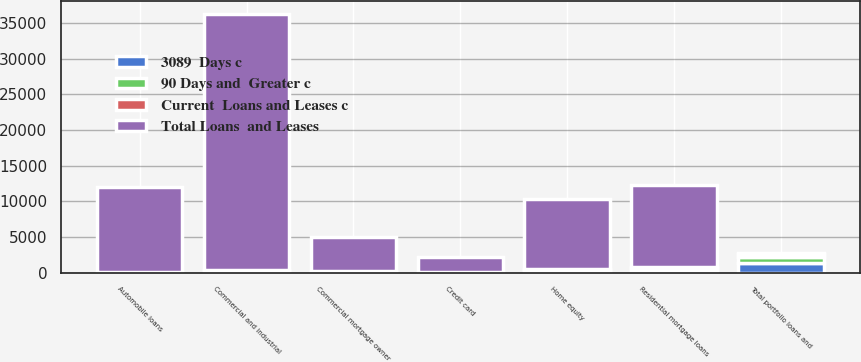<chart> <loc_0><loc_0><loc_500><loc_500><stacked_bar_chart><ecel><fcel>Commercial and industrial<fcel>Commercial mortgage owner<fcel>Residential mortgage loans<fcel>Home equity<fcel>Automobile loans<fcel>Credit card<fcel>Total portfolio loans and<nl><fcel>Total Loans  and Leases<fcel>35826<fcel>4752<fcel>11547<fcel>9782<fcel>11900<fcel>2025<fcel>166<nl><fcel>Current  Loans and Leases c<fcel>46<fcel>29<fcel>87<fcel>126<fcel>62<fcel>38<fcel>413<nl><fcel>90 Days and  Greater c<fcel>166<fcel>95<fcel>307<fcel>110<fcel>10<fcel>34<fcel>912<nl><fcel>3089  Days c<fcel>212<fcel>124<fcel>394<fcel>236<fcel>72<fcel>72<fcel>1325<nl></chart> 